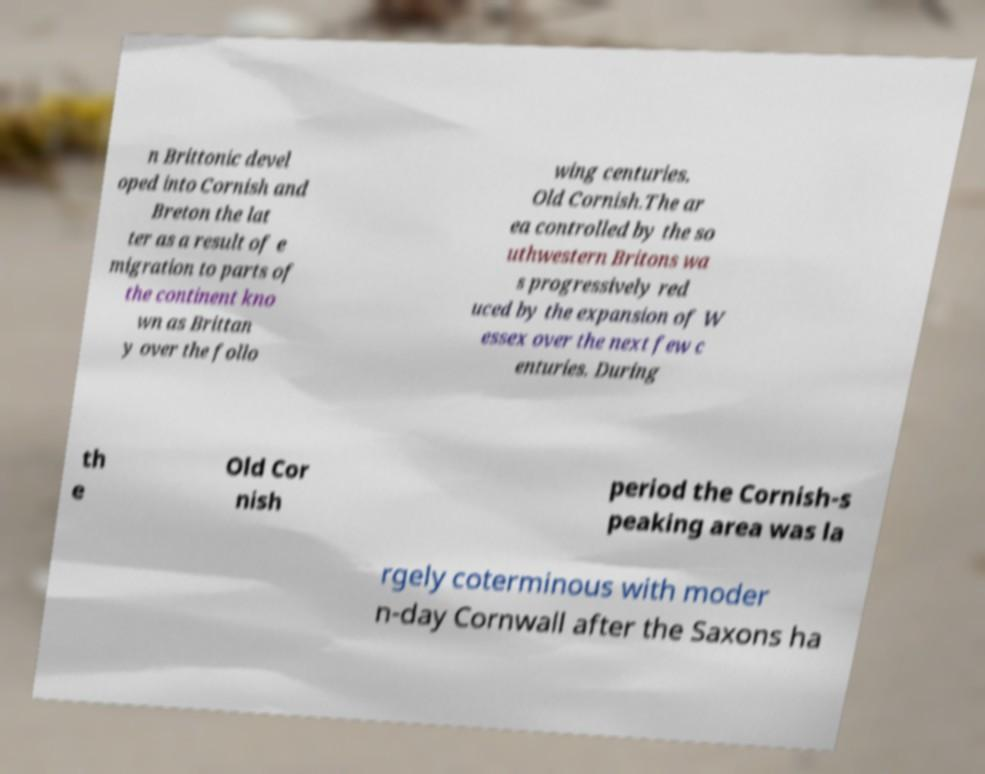Can you read and provide the text displayed in the image?This photo seems to have some interesting text. Can you extract and type it out for me? n Brittonic devel oped into Cornish and Breton the lat ter as a result of e migration to parts of the continent kno wn as Brittan y over the follo wing centuries. Old Cornish.The ar ea controlled by the so uthwestern Britons wa s progressively red uced by the expansion of W essex over the next few c enturies. During th e Old Cor nish period the Cornish-s peaking area was la rgely coterminous with moder n-day Cornwall after the Saxons ha 